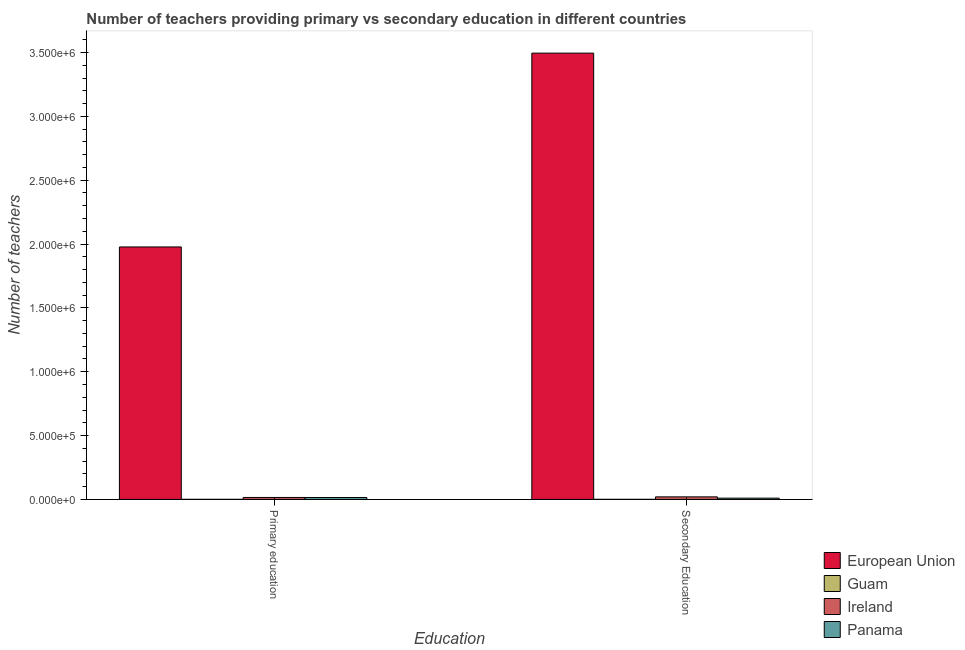How many different coloured bars are there?
Keep it short and to the point. 4. Are the number of bars on each tick of the X-axis equal?
Ensure brevity in your answer.  Yes. How many bars are there on the 2nd tick from the left?
Make the answer very short. 4. What is the number of primary teachers in Guam?
Offer a very short reply. 775. Across all countries, what is the maximum number of secondary teachers?
Keep it short and to the point. 3.50e+06. Across all countries, what is the minimum number of secondary teachers?
Your answer should be very brief. 880. In which country was the number of secondary teachers minimum?
Offer a very short reply. Guam. What is the total number of primary teachers in the graph?
Ensure brevity in your answer.  2.01e+06. What is the difference between the number of primary teachers in European Union and that in Guam?
Offer a terse response. 1.98e+06. What is the difference between the number of secondary teachers in European Union and the number of primary teachers in Panama?
Make the answer very short. 3.48e+06. What is the average number of secondary teachers per country?
Offer a terse response. 8.82e+05. What is the difference between the number of primary teachers and number of secondary teachers in Guam?
Keep it short and to the point. -105. What is the ratio of the number of secondary teachers in Panama to that in European Union?
Your response must be concise. 0. What does the 4th bar from the left in Primary education represents?
Ensure brevity in your answer.  Panama. What does the 2nd bar from the right in Primary education represents?
Offer a very short reply. Ireland. How many bars are there?
Keep it short and to the point. 8. How many countries are there in the graph?
Keep it short and to the point. 4. What is the difference between two consecutive major ticks on the Y-axis?
Your response must be concise. 5.00e+05. Where does the legend appear in the graph?
Ensure brevity in your answer.  Bottom right. How are the legend labels stacked?
Your answer should be compact. Vertical. What is the title of the graph?
Make the answer very short. Number of teachers providing primary vs secondary education in different countries. What is the label or title of the X-axis?
Your response must be concise. Education. What is the label or title of the Y-axis?
Offer a terse response. Number of teachers. What is the Number of teachers of European Union in Primary education?
Your answer should be compact. 1.98e+06. What is the Number of teachers of Guam in Primary education?
Provide a succinct answer. 775. What is the Number of teachers in Ireland in Primary education?
Your response must be concise. 1.54e+04. What is the Number of teachers in Panama in Primary education?
Offer a very short reply. 1.51e+04. What is the Number of teachers of European Union in Secondary Education?
Offer a very short reply. 3.50e+06. What is the Number of teachers in Guam in Secondary Education?
Your answer should be compact. 880. What is the Number of teachers of Ireland in Secondary Education?
Make the answer very short. 2.01e+04. What is the Number of teachers in Panama in Secondary Education?
Keep it short and to the point. 9968. Across all Education, what is the maximum Number of teachers in European Union?
Give a very brief answer. 3.50e+06. Across all Education, what is the maximum Number of teachers of Guam?
Make the answer very short. 880. Across all Education, what is the maximum Number of teachers in Ireland?
Your answer should be very brief. 2.01e+04. Across all Education, what is the maximum Number of teachers of Panama?
Give a very brief answer. 1.51e+04. Across all Education, what is the minimum Number of teachers of European Union?
Provide a succinct answer. 1.98e+06. Across all Education, what is the minimum Number of teachers of Guam?
Your answer should be very brief. 775. Across all Education, what is the minimum Number of teachers in Ireland?
Keep it short and to the point. 1.54e+04. Across all Education, what is the minimum Number of teachers in Panama?
Offer a terse response. 9968. What is the total Number of teachers of European Union in the graph?
Provide a succinct answer. 5.47e+06. What is the total Number of teachers of Guam in the graph?
Your answer should be compact. 1655. What is the total Number of teachers in Ireland in the graph?
Ensure brevity in your answer.  3.55e+04. What is the total Number of teachers of Panama in the graph?
Provide a succinct answer. 2.50e+04. What is the difference between the Number of teachers in European Union in Primary education and that in Secondary Education?
Provide a succinct answer. -1.52e+06. What is the difference between the Number of teachers in Guam in Primary education and that in Secondary Education?
Keep it short and to the point. -105. What is the difference between the Number of teachers in Ireland in Primary education and that in Secondary Education?
Ensure brevity in your answer.  -4701. What is the difference between the Number of teachers of Panama in Primary education and that in Secondary Education?
Provide a succinct answer. 5094. What is the difference between the Number of teachers in European Union in Primary education and the Number of teachers in Guam in Secondary Education?
Provide a succinct answer. 1.98e+06. What is the difference between the Number of teachers in European Union in Primary education and the Number of teachers in Ireland in Secondary Education?
Your answer should be very brief. 1.96e+06. What is the difference between the Number of teachers in European Union in Primary education and the Number of teachers in Panama in Secondary Education?
Ensure brevity in your answer.  1.97e+06. What is the difference between the Number of teachers in Guam in Primary education and the Number of teachers in Ireland in Secondary Education?
Provide a succinct answer. -1.93e+04. What is the difference between the Number of teachers of Guam in Primary education and the Number of teachers of Panama in Secondary Education?
Your answer should be compact. -9193. What is the difference between the Number of teachers in Ireland in Primary education and the Number of teachers in Panama in Secondary Education?
Provide a short and direct response. 5425. What is the average Number of teachers in European Union per Education?
Offer a very short reply. 2.74e+06. What is the average Number of teachers in Guam per Education?
Give a very brief answer. 827.5. What is the average Number of teachers of Ireland per Education?
Make the answer very short. 1.77e+04. What is the average Number of teachers of Panama per Education?
Offer a terse response. 1.25e+04. What is the difference between the Number of teachers of European Union and Number of teachers of Guam in Primary education?
Keep it short and to the point. 1.98e+06. What is the difference between the Number of teachers in European Union and Number of teachers in Ireland in Primary education?
Give a very brief answer. 1.96e+06. What is the difference between the Number of teachers of European Union and Number of teachers of Panama in Primary education?
Provide a succinct answer. 1.96e+06. What is the difference between the Number of teachers in Guam and Number of teachers in Ireland in Primary education?
Ensure brevity in your answer.  -1.46e+04. What is the difference between the Number of teachers of Guam and Number of teachers of Panama in Primary education?
Provide a succinct answer. -1.43e+04. What is the difference between the Number of teachers of Ireland and Number of teachers of Panama in Primary education?
Your response must be concise. 331. What is the difference between the Number of teachers in European Union and Number of teachers in Guam in Secondary Education?
Your answer should be very brief. 3.49e+06. What is the difference between the Number of teachers of European Union and Number of teachers of Ireland in Secondary Education?
Offer a terse response. 3.48e+06. What is the difference between the Number of teachers in European Union and Number of teachers in Panama in Secondary Education?
Provide a succinct answer. 3.49e+06. What is the difference between the Number of teachers in Guam and Number of teachers in Ireland in Secondary Education?
Offer a terse response. -1.92e+04. What is the difference between the Number of teachers in Guam and Number of teachers in Panama in Secondary Education?
Offer a terse response. -9088. What is the difference between the Number of teachers in Ireland and Number of teachers in Panama in Secondary Education?
Offer a very short reply. 1.01e+04. What is the ratio of the Number of teachers of European Union in Primary education to that in Secondary Education?
Make the answer very short. 0.57. What is the ratio of the Number of teachers in Guam in Primary education to that in Secondary Education?
Make the answer very short. 0.88. What is the ratio of the Number of teachers in Ireland in Primary education to that in Secondary Education?
Provide a short and direct response. 0.77. What is the ratio of the Number of teachers in Panama in Primary education to that in Secondary Education?
Your answer should be compact. 1.51. What is the difference between the highest and the second highest Number of teachers of European Union?
Provide a short and direct response. 1.52e+06. What is the difference between the highest and the second highest Number of teachers of Guam?
Offer a terse response. 105. What is the difference between the highest and the second highest Number of teachers of Ireland?
Make the answer very short. 4701. What is the difference between the highest and the second highest Number of teachers in Panama?
Your answer should be very brief. 5094. What is the difference between the highest and the lowest Number of teachers in European Union?
Ensure brevity in your answer.  1.52e+06. What is the difference between the highest and the lowest Number of teachers of Guam?
Provide a short and direct response. 105. What is the difference between the highest and the lowest Number of teachers of Ireland?
Provide a short and direct response. 4701. What is the difference between the highest and the lowest Number of teachers of Panama?
Provide a succinct answer. 5094. 